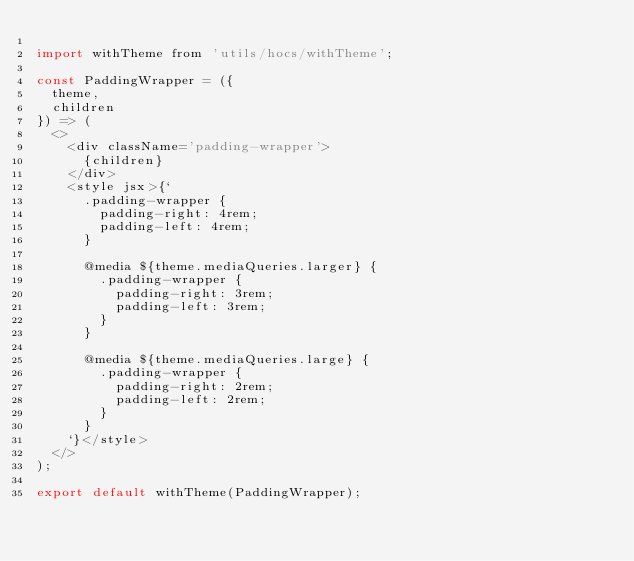Convert code to text. <code><loc_0><loc_0><loc_500><loc_500><_JavaScript_>
import withTheme from 'utils/hocs/withTheme';

const PaddingWrapper = ({
  theme,
  children
}) => (
  <>
    <div className='padding-wrapper'>
      {children}
    </div>
    <style jsx>{`
      .padding-wrapper {
        padding-right: 4rem;
        padding-left: 4rem;
      }

      @media ${theme.mediaQueries.larger} {
        .padding-wrapper {
          padding-right: 3rem;
          padding-left: 3rem;
        }
      }

      @media ${theme.mediaQueries.large} {
        .padding-wrapper {
          padding-right: 2rem;
          padding-left: 2rem;
        }
      }
    `}</style>
  </>
);

export default withTheme(PaddingWrapper);
</code> 